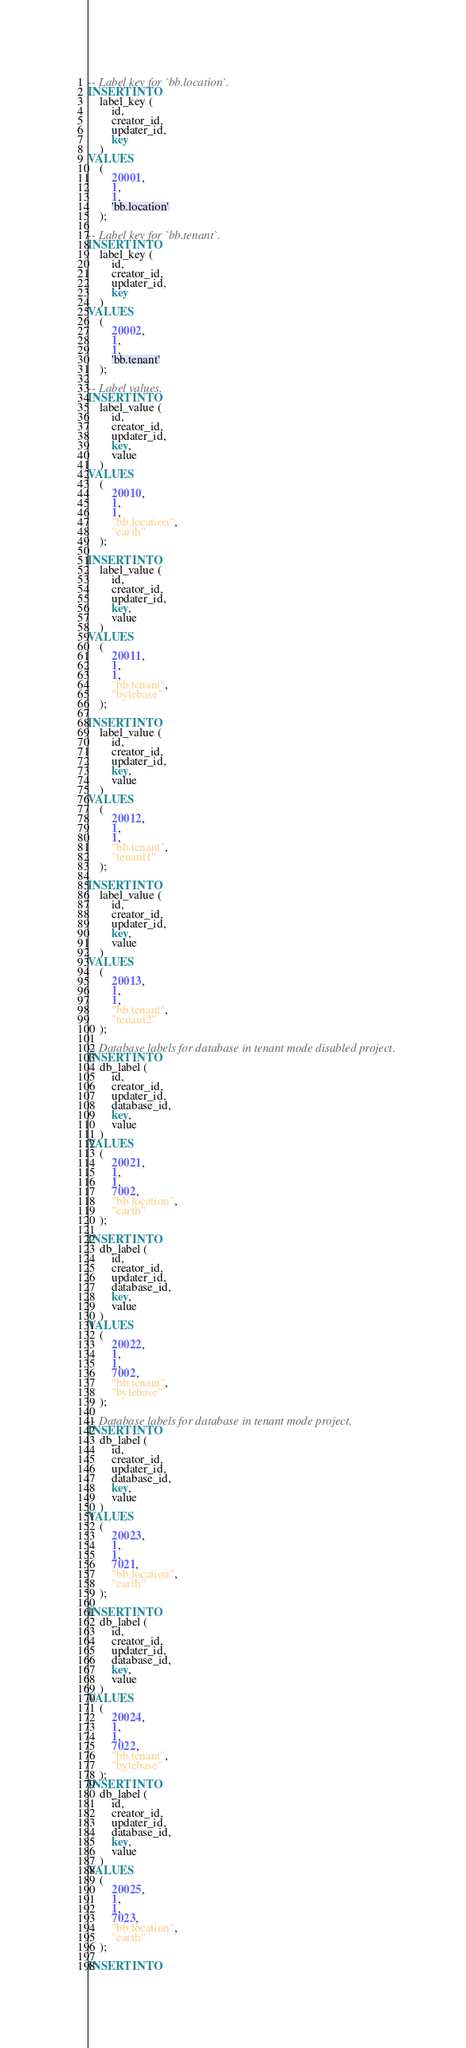Convert code to text. <code><loc_0><loc_0><loc_500><loc_500><_SQL_>-- Label key for `bb.location`.
INSERT INTO
    label_key (
        id,
        creator_id,
        updater_id,
        key
    )
VALUES
    (
        20001,
        1,
        1,
        'bb.location'
    );

-- Label key for `bb.tenant`.
INSERT INTO
    label_key (
        id,
        creator_id,
        updater_id,
        key
    )
VALUES
    (
        20002,
        1,
        1,
        'bb.tenant'
    );

-- Label values.
INSERT INTO
    label_value (
        id,
        creator_id,
        updater_id,
        key,
        value
    )
VALUES
    (
        20010,
        1,
        1,
        "bb.location",
        "earth"
    );

INSERT INTO
    label_value (
        id,
        creator_id,
        updater_id,
        key,
        value
    )
VALUES
    (
        20011,
        1,
        1,
        "bb.tenant",
        "bytebase"
    );

INSERT INTO
    label_value (
        id,
        creator_id,
        updater_id,
        key,
        value
    )
VALUES
    (
        20012,
        1,
        1,
        "bb.tenant",
        "tenant1"
    );

INSERT INTO
    label_value (
        id,
        creator_id,
        updater_id,
        key,
        value
    )
VALUES
    (
        20013,
        1,
        1,
        "bb.tenant",
        "tenant2"
    );

-- Database labels for database in tenant mode disabled project.
INSERT INTO
    db_label (
        id,
        creator_id,
        updater_id,
        database_id,
        key,
        value
    )
VALUES
    (
        20021,
        1,
        1,
        7002,
        "bb.location",
        "earth"
    );

INSERT INTO
    db_label (
        id,
        creator_id,
        updater_id,
        database_id,
        key,
        value
    )
VALUES
    (
        20022,
        1,
        1,
        7002,
        "bb.tenant",
        "bytebase"
    );

-- Database labels for database in tenant mode project.
INSERT INTO
    db_label (
        id,
        creator_id,
        updater_id,
        database_id,
        key,
        value
    )
VALUES
    (
        20023,
        1,
        1,
        7021,
        "bb.location",
        "earth"
    );

INSERT INTO
    db_label (
        id,
        creator_id,
        updater_id,
        database_id,
        key,
        value
    )
VALUES
    (
        20024,
        1,
        1,
        7022,
        "bb.tenant",
        "bytebase"
    );
INSERT INTO
    db_label (
        id,
        creator_id,
        updater_id,
        database_id,
        key,
        value
    )
VALUES
    (
        20025,
        1,
        1,
        7023,
        "bb.location",
        "earth"
    );

INSERT INTO</code> 